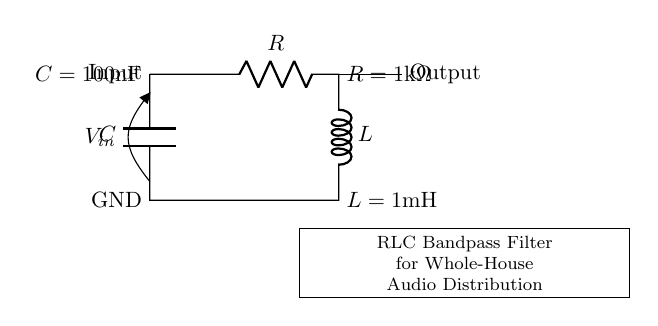What is the resistance value in the circuit? The resistance value is indicated next to the resistor symbol, which shows that R equals one kilohm.
Answer: one kilohm What components are present in this RLC circuit? The circuit diagram clearly shows three components: a resistor, an inductor, and a capacitor.
Answer: resistor, inductor, capacitor In what configuration is the inductor positioned relative to the resistor and capacitor? The inductor is positioned in series with the resistor and in parallel with the capacitor. This can be inferred by examining the connectivity of the components in the circuit diagram.
Answer: series with resistor, parallel with capacitor What is the inductance value of the inductor? The inductance value is specified next to the inductor symbol, which shows that L equals one millihenry.
Answer: one millihenry What is the capacitance value of the capacitor? The capacitance value is mentioned next to the capacitor symbol, which indicates that C equals one hundred nanofarads.
Answer: one hundred nanofarads What is the purpose of this RLC circuit? The labeling at the bottom of the circuit diagram states that this is an RLC bandpass filter designed for audio distribution.
Answer: audio distribution How would you describe the overall function of this filter circuit? The circuit allows signals within a specific frequency range to pass while attenuating frequencies outside of this range. This is characteristic of a bandpass filter configuration.
Answer: bandpass filter 